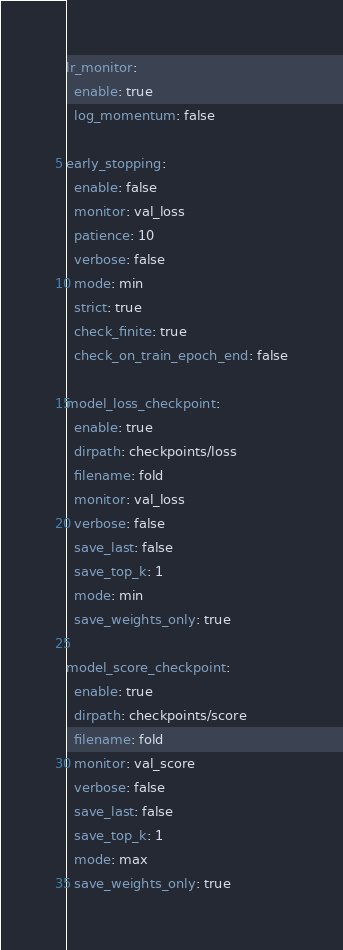<code> <loc_0><loc_0><loc_500><loc_500><_YAML_>lr_monitor:
  enable: true
  log_momentum: false

early_stopping:
  enable: false
  monitor: val_loss
  patience: 10
  verbose: false
  mode: min
  strict: true
  check_finite: true
  check_on_train_epoch_end: false

model_loss_checkpoint:
  enable: true
  dirpath: checkpoints/loss
  filename: fold
  monitor: val_loss
  verbose: false
  save_last: false
  save_top_k: 1
  mode: min
  save_weights_only: true

model_score_checkpoint:
  enable: true
  dirpath: checkpoints/score
  filename: fold
  monitor: val_score
  verbose: false
  save_last: false
  save_top_k: 1
  mode: max
  save_weights_only: true
</code> 